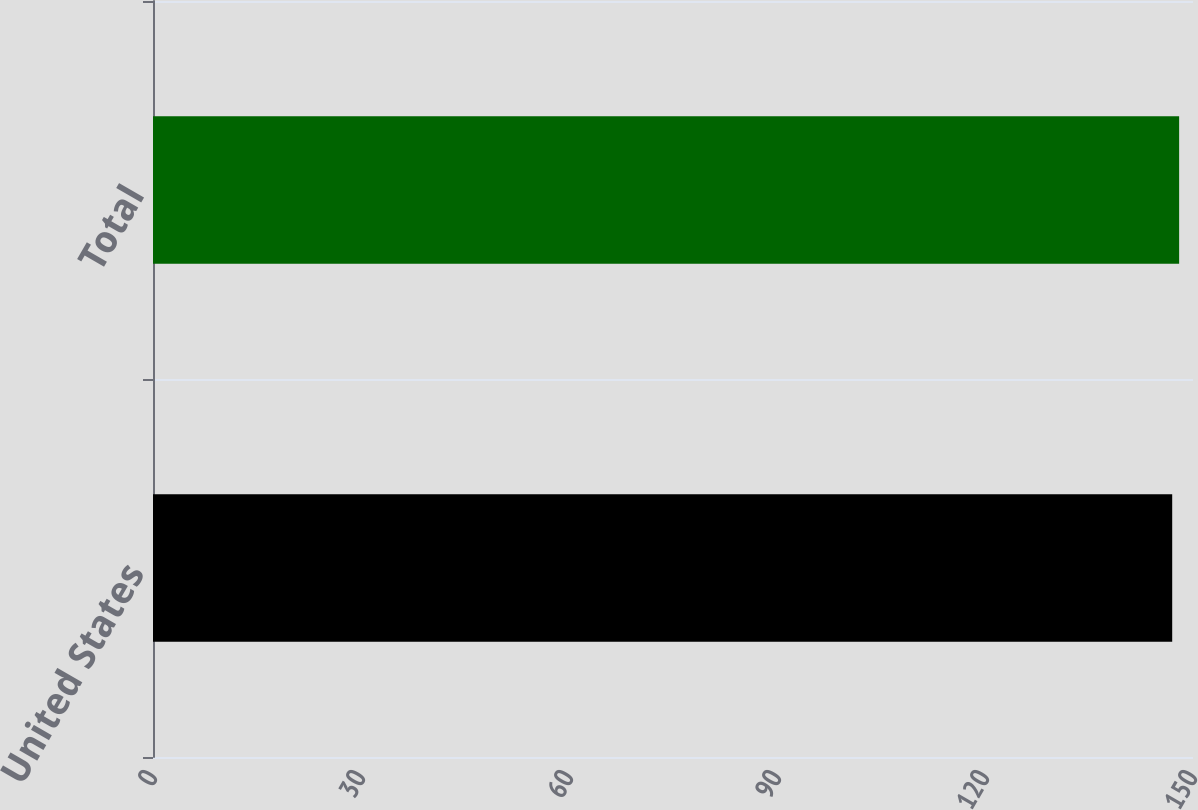Convert chart. <chart><loc_0><loc_0><loc_500><loc_500><bar_chart><fcel>United States<fcel>Total<nl><fcel>147<fcel>148<nl></chart> 